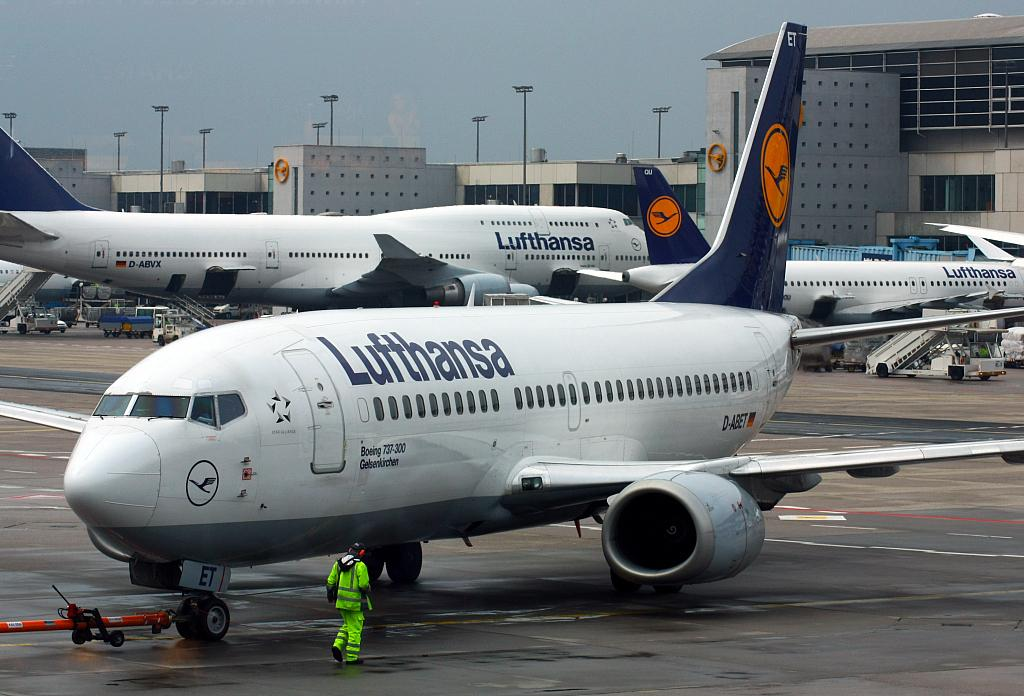<image>
Render a clear and concise summary of the photo. an airplane from the Lufthansa company is sitting on the tarmack 